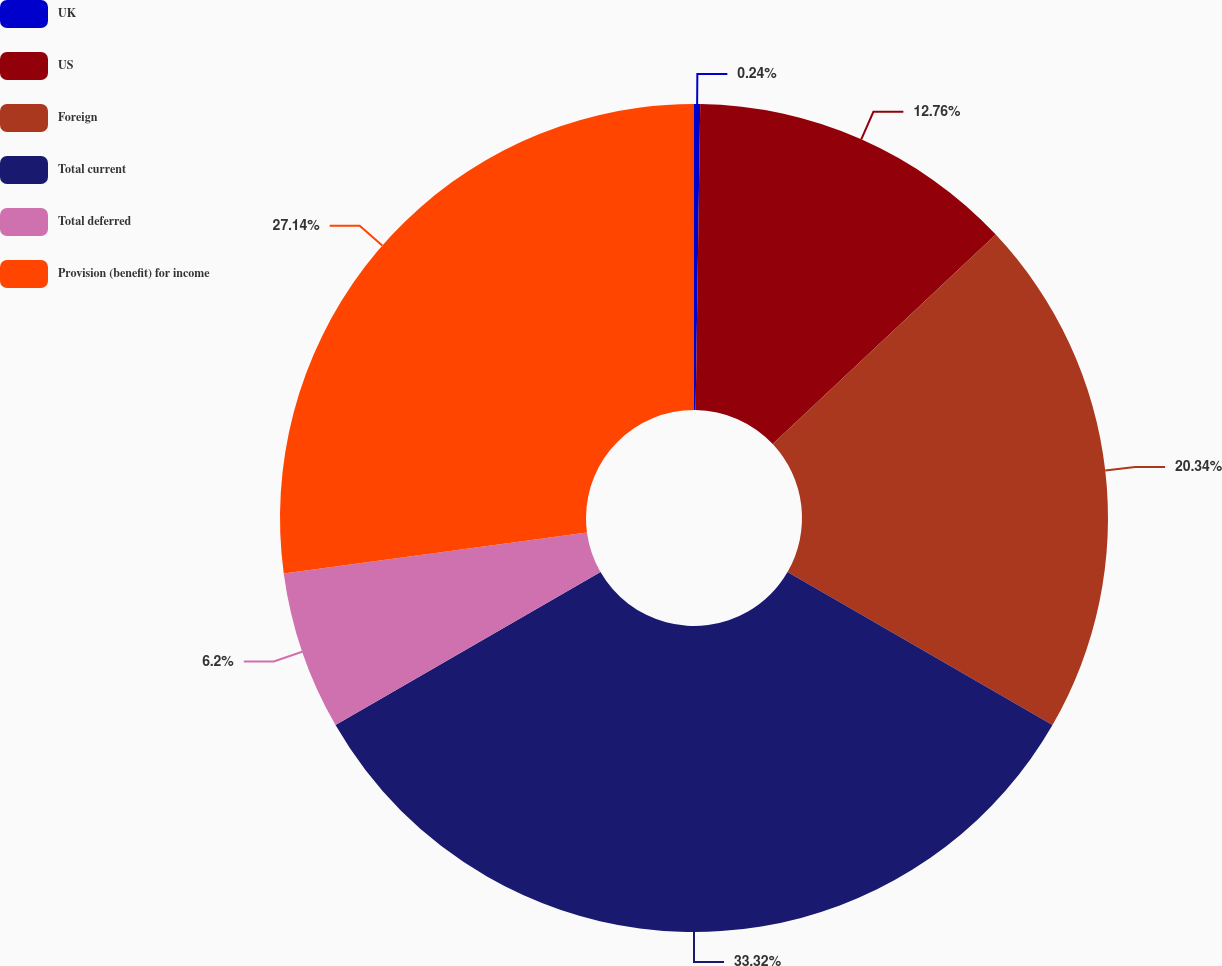Convert chart to OTSL. <chart><loc_0><loc_0><loc_500><loc_500><pie_chart><fcel>UK<fcel>US<fcel>Foreign<fcel>Total current<fcel>Total deferred<fcel>Provision (benefit) for income<nl><fcel>0.24%<fcel>12.76%<fcel>20.34%<fcel>33.33%<fcel>6.2%<fcel>27.14%<nl></chart> 